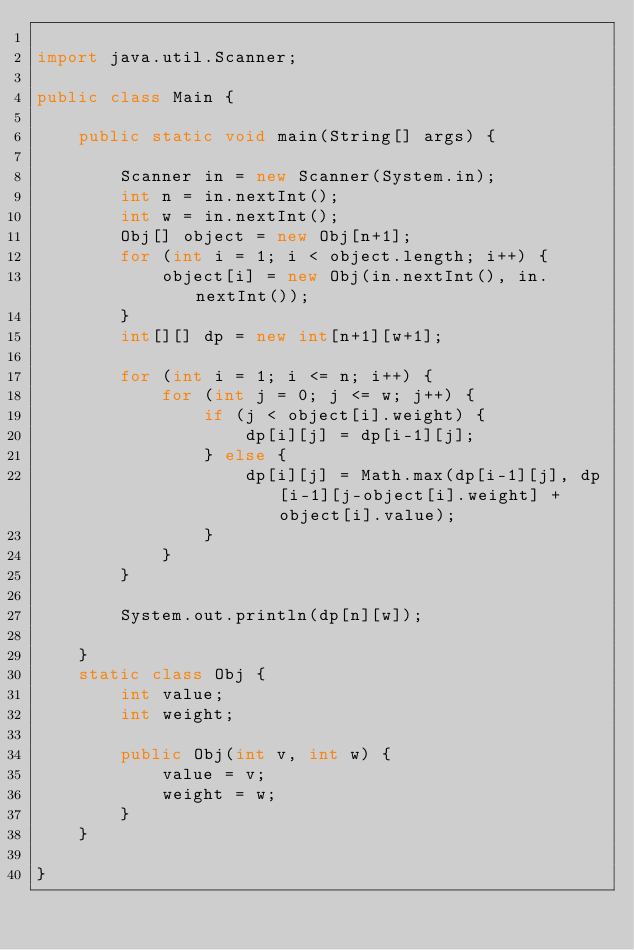<code> <loc_0><loc_0><loc_500><loc_500><_Java_>
import java.util.Scanner;

public class Main {

	public static void main(String[] args) {

		Scanner in = new Scanner(System.in);
		int n = in.nextInt();
		int w = in.nextInt();
		Obj[] object = new Obj[n+1];
		for (int i = 1; i < object.length; i++) {
			object[i] = new Obj(in.nextInt(), in.nextInt());
		}
		int[][] dp = new int[n+1][w+1];

		for (int i = 1; i <= n; i++) {
			for (int j = 0; j <= w; j++) {
				if (j < object[i].weight) {
					dp[i][j] = dp[i-1][j];
				} else {
					dp[i][j] = Math.max(dp[i-1][j], dp[i-1][j-object[i].weight] + object[i].value);
				}
			}
		}

		System.out.println(dp[n][w]);

	}
	static class Obj {
		int value;
		int weight;

		public Obj(int v, int w) {
			value = v;
			weight = w;
		}
	}

}

</code> 